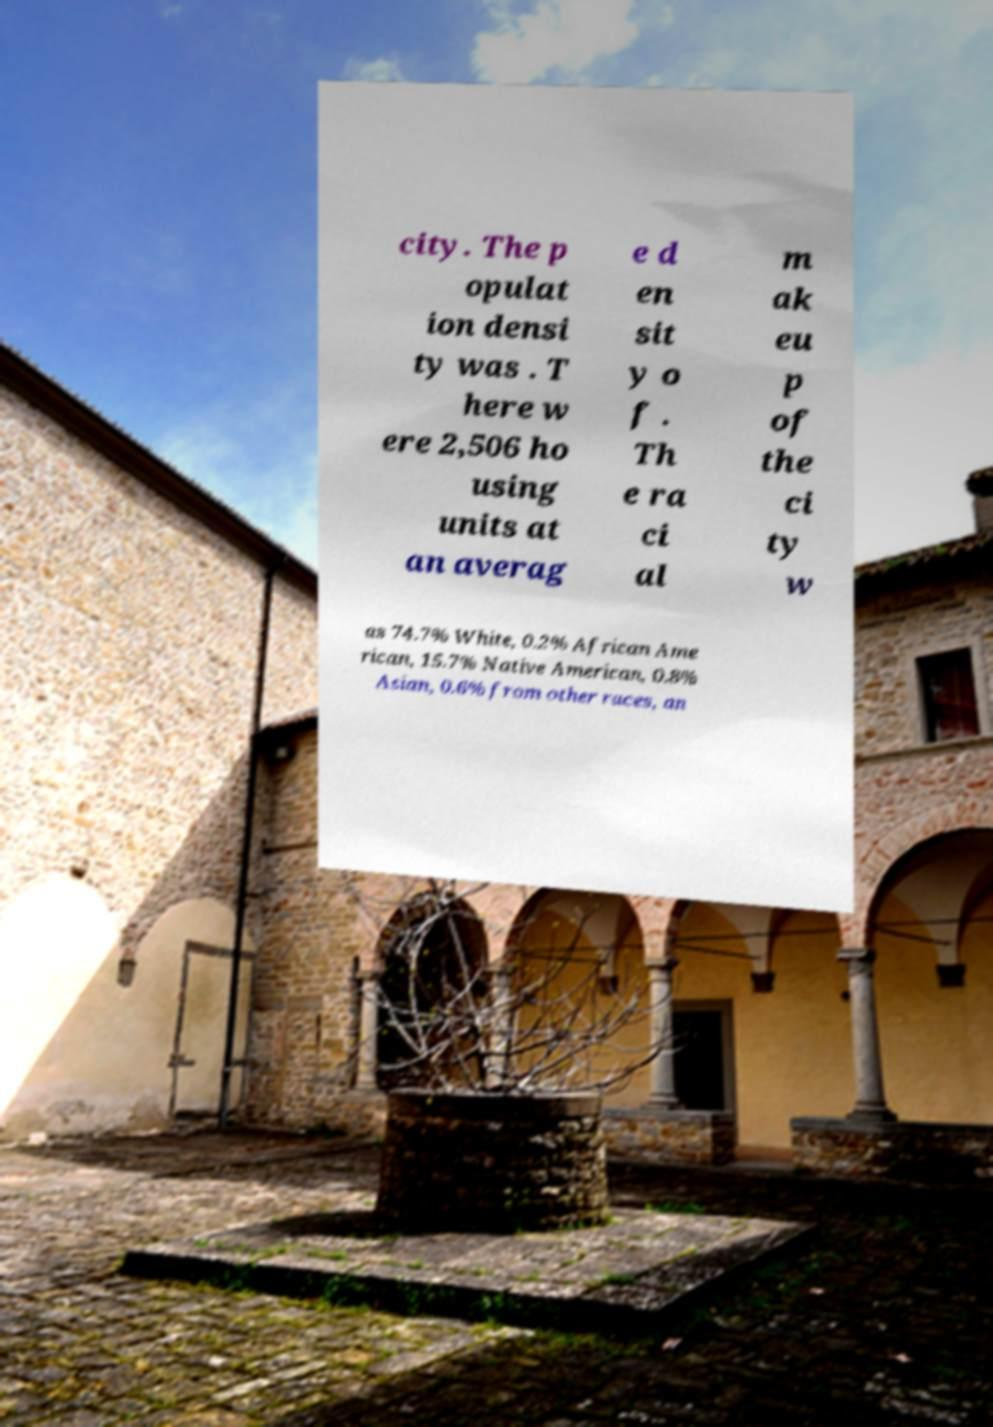Can you accurately transcribe the text from the provided image for me? city. The p opulat ion densi ty was . T here w ere 2,506 ho using units at an averag e d en sit y o f . Th e ra ci al m ak eu p of the ci ty w as 74.7% White, 0.2% African Ame rican, 15.7% Native American, 0.8% Asian, 0.6% from other races, an 